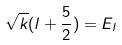Convert formula to latex. <formula><loc_0><loc_0><loc_500><loc_500>\sqrt { k } ( l + \frac { 5 } { 2 } ) = E _ { l }</formula> 